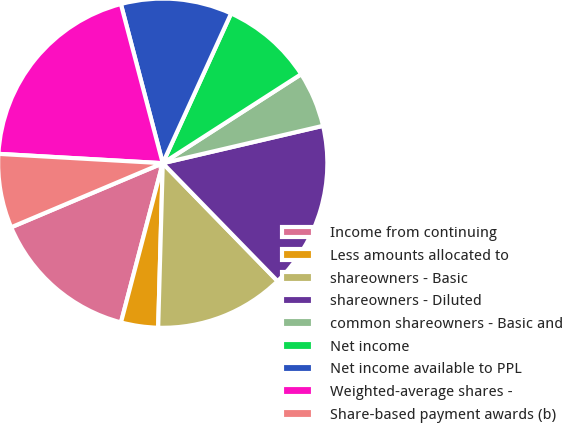<chart> <loc_0><loc_0><loc_500><loc_500><pie_chart><fcel>Income from continuing<fcel>Less amounts allocated to<fcel>shareowners - Basic<fcel>shareowners - Diluted<fcel>common shareowners - Basic and<fcel>Net income<fcel>Net income available to PPL<fcel>Weighted-average shares -<fcel>Share-based payment awards (b)<nl><fcel>14.55%<fcel>3.64%<fcel>12.73%<fcel>16.36%<fcel>5.45%<fcel>9.09%<fcel>10.91%<fcel>20.0%<fcel>7.27%<nl></chart> 